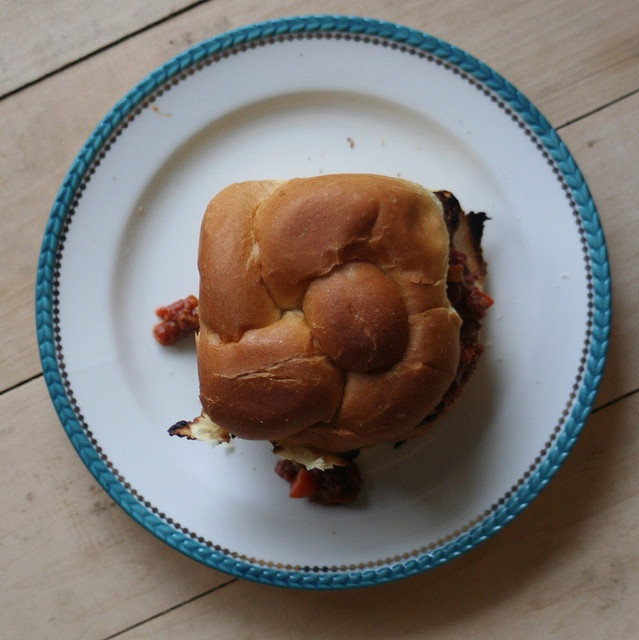Describe the objects in this image and their specific colors. I can see dining table in darkgray, black, maroon, gray, and lightgray tones and sandwich in darkgray, maroon, black, brown, and gray tones in this image. 